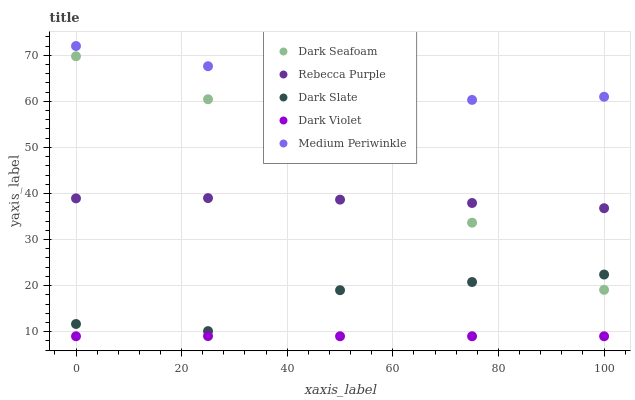Does Dark Violet have the minimum area under the curve?
Answer yes or no. Yes. Does Medium Periwinkle have the maximum area under the curve?
Answer yes or no. Yes. Does Dark Seafoam have the minimum area under the curve?
Answer yes or no. No. Does Dark Seafoam have the maximum area under the curve?
Answer yes or no. No. Is Dark Violet the smoothest?
Answer yes or no. Yes. Is Dark Slate the roughest?
Answer yes or no. Yes. Is Dark Seafoam the smoothest?
Answer yes or no. No. Is Dark Seafoam the roughest?
Answer yes or no. No. Does Dark Violet have the lowest value?
Answer yes or no. Yes. Does Dark Seafoam have the lowest value?
Answer yes or no. No. Does Medium Periwinkle have the highest value?
Answer yes or no. Yes. Does Dark Seafoam have the highest value?
Answer yes or no. No. Is Dark Violet less than Medium Periwinkle?
Answer yes or no. Yes. Is Rebecca Purple greater than Dark Slate?
Answer yes or no. Yes. Does Dark Seafoam intersect Rebecca Purple?
Answer yes or no. Yes. Is Dark Seafoam less than Rebecca Purple?
Answer yes or no. No. Is Dark Seafoam greater than Rebecca Purple?
Answer yes or no. No. Does Dark Violet intersect Medium Periwinkle?
Answer yes or no. No. 